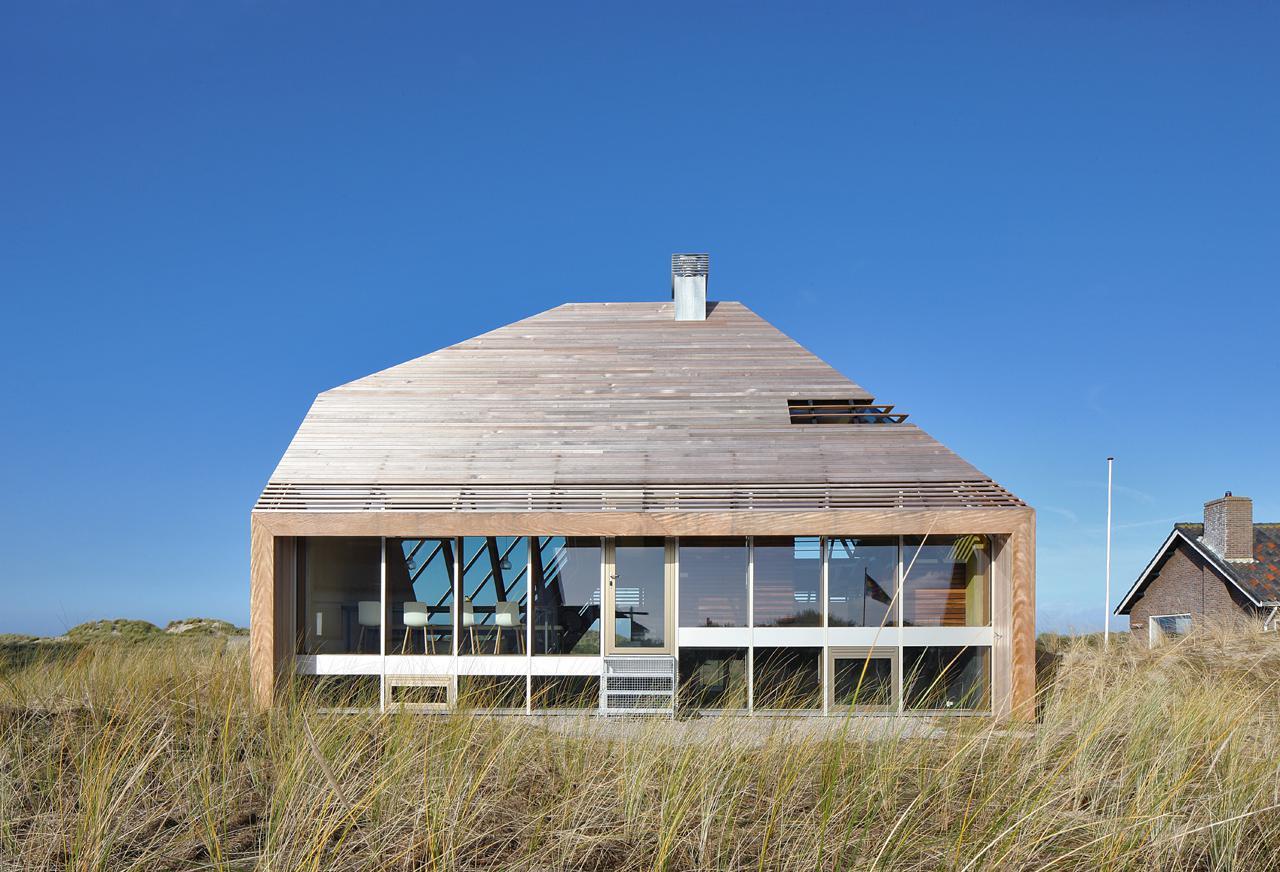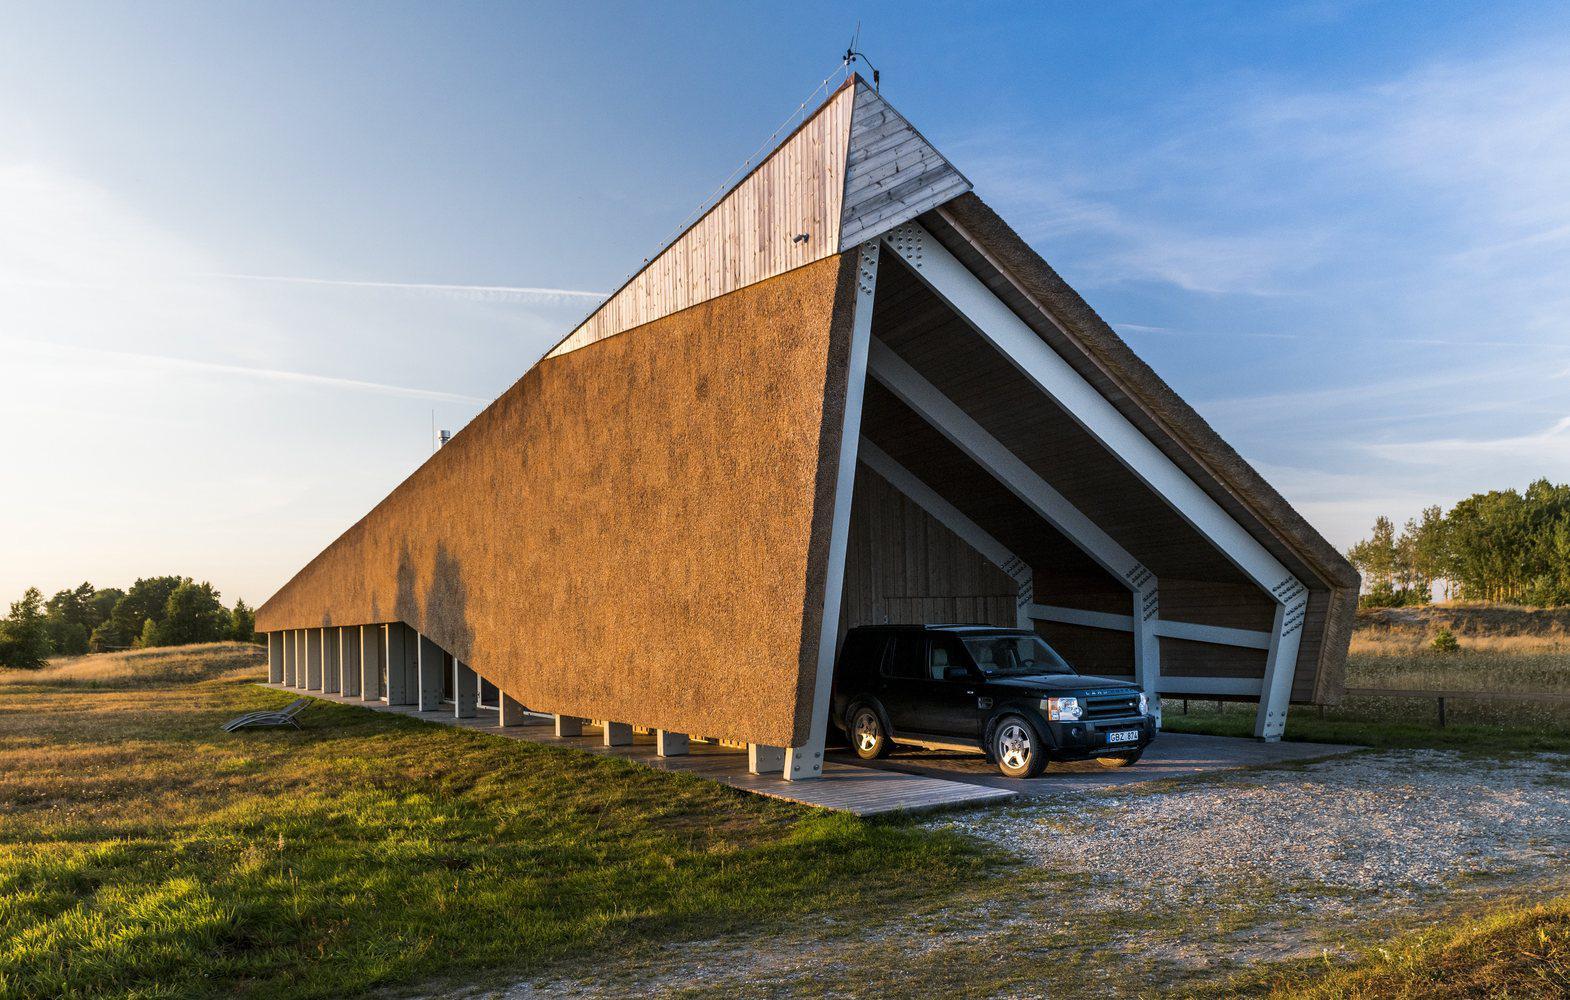The first image is the image on the left, the second image is the image on the right. Examine the images to the left and right. Is the description "In the left image, the roof is currently being thatched; the thatching has started, but has not completed." accurate? Answer yes or no. No. The first image is the image on the left, the second image is the image on the right. Analyze the images presented: Is the assertion "In one image, thatch is piled in a heap in front of a non-brick buildling being re-thatched, with new thatch on the right side of the roof." valid? Answer yes or no. No. 